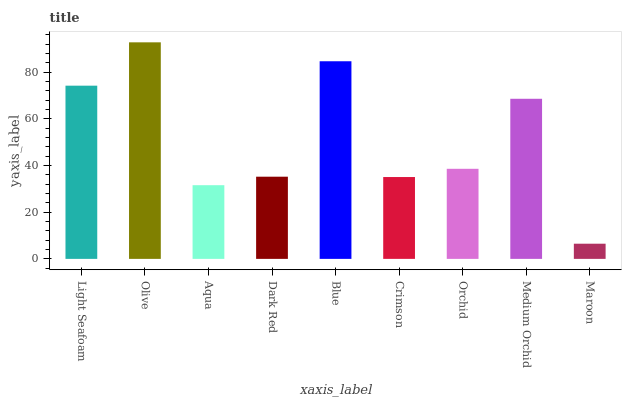Is Maroon the minimum?
Answer yes or no. Yes. Is Olive the maximum?
Answer yes or no. Yes. Is Aqua the minimum?
Answer yes or no. No. Is Aqua the maximum?
Answer yes or no. No. Is Olive greater than Aqua?
Answer yes or no. Yes. Is Aqua less than Olive?
Answer yes or no. Yes. Is Aqua greater than Olive?
Answer yes or no. No. Is Olive less than Aqua?
Answer yes or no. No. Is Orchid the high median?
Answer yes or no. Yes. Is Orchid the low median?
Answer yes or no. Yes. Is Light Seafoam the high median?
Answer yes or no. No. Is Olive the low median?
Answer yes or no. No. 